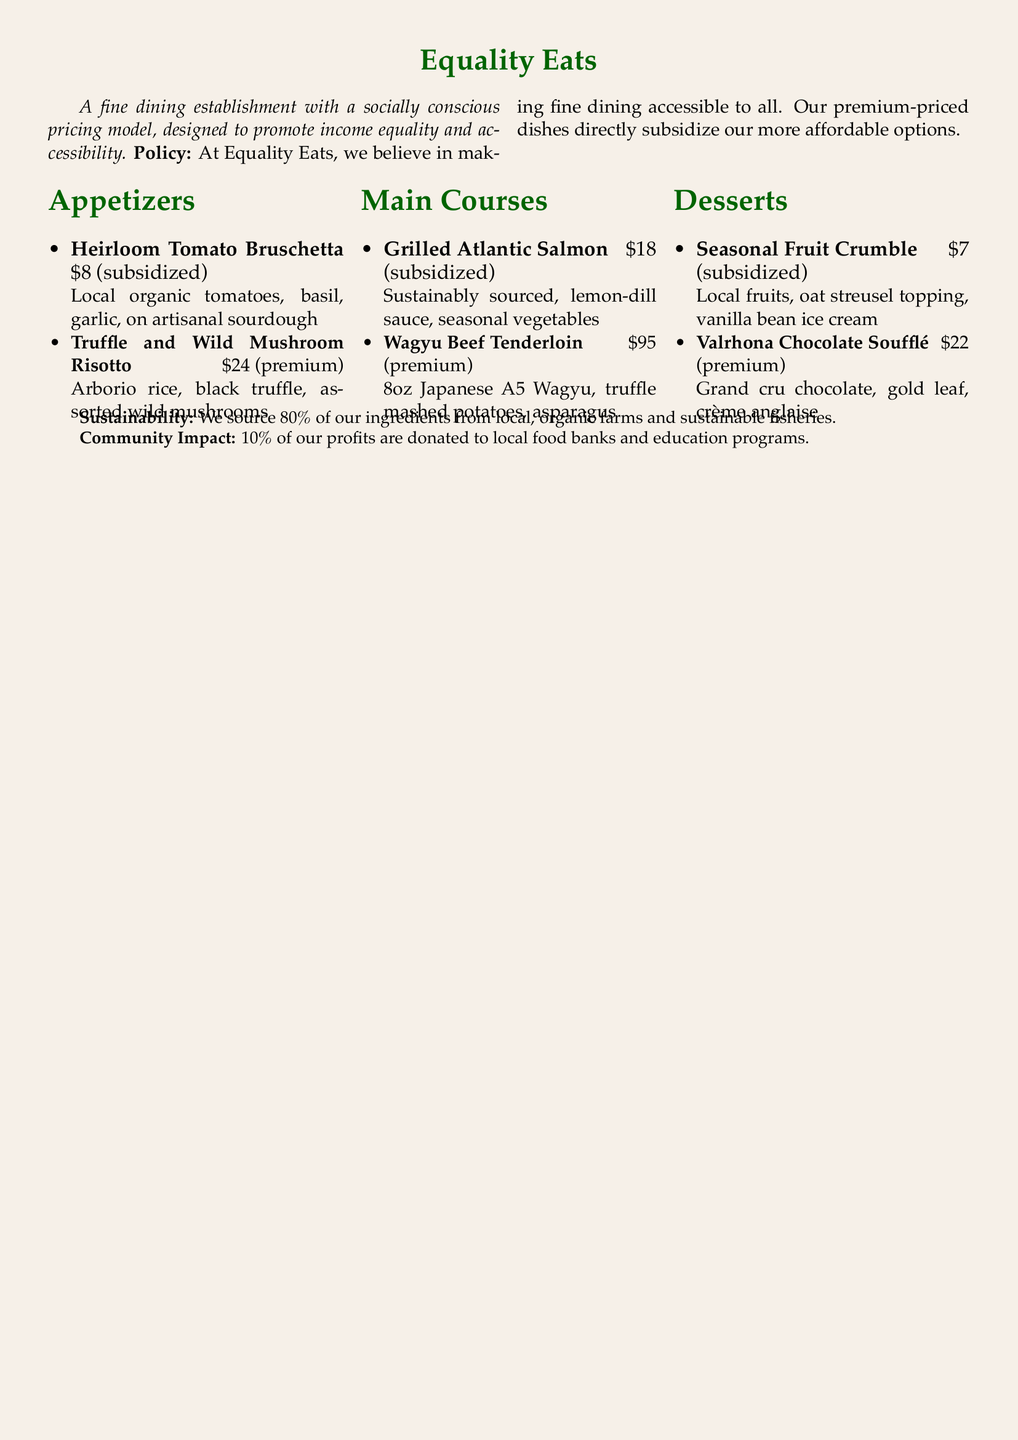What is the name of the restaurant? The name of the restaurant is stated at the top of the menu.
Answer: Equality Eats What is the price of the Heirloom Tomato Bruschetta? The price is listed next to the dish in the appetizers section.
Answer: 8 How much do profits go to local food banks? The percentage of profits donated is mentioned in the sustainability section.
Answer: 10% What type of beef is used in the Wagyu Beef Tenderloin? The type of beef is described in the main courses section.
Answer: Japanese A5 Wagyu How many courses are listed on the menu? The number of sections in the menu indicates the number of courses.
Answer: 3 What is the total price for the premium dessert? The price is available with the dessert description in the menu.
Answer: 22 Which dish is subsidized and comes with seasonal vegetables? The description of the dish helps to identify it in the main courses.
Answer: Grilled Atlantic Salmon What source percentage of ingredients comes from local farms? The source percentage is provided in the sustainability section.
Answer: 80% What is the main idea behind the restaurant's pricing model? The pricing model is discussed at the beginning of the menu.
Answer: Socially conscious pricing model 